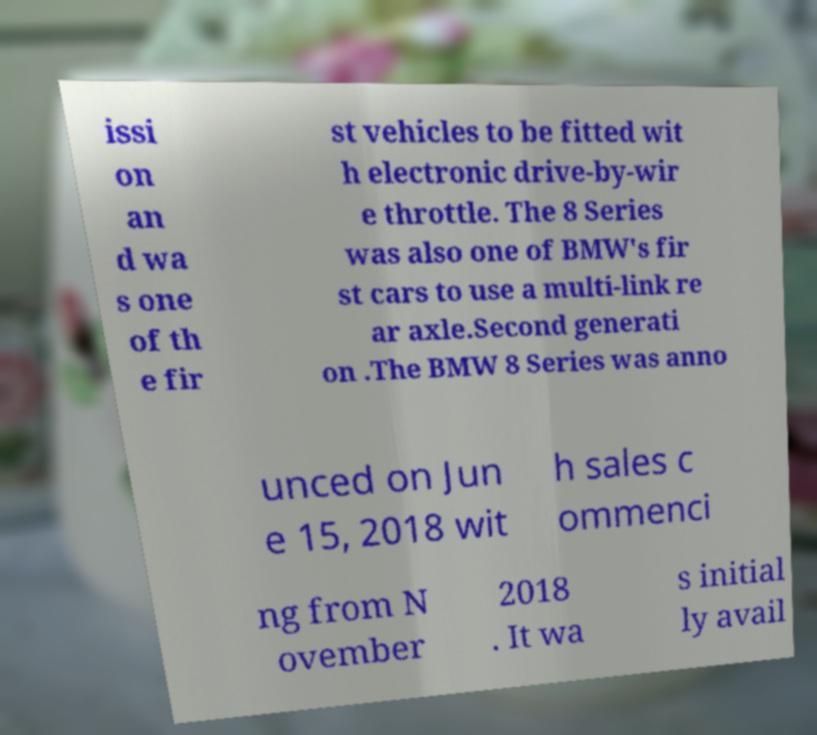Could you extract and type out the text from this image? issi on an d wa s one of th e fir st vehicles to be fitted wit h electronic drive-by-wir e throttle. The 8 Series was also one of BMW's fir st cars to use a multi-link re ar axle.Second generati on .The BMW 8 Series was anno unced on Jun e 15, 2018 wit h sales c ommenci ng from N ovember 2018 . It wa s initial ly avail 